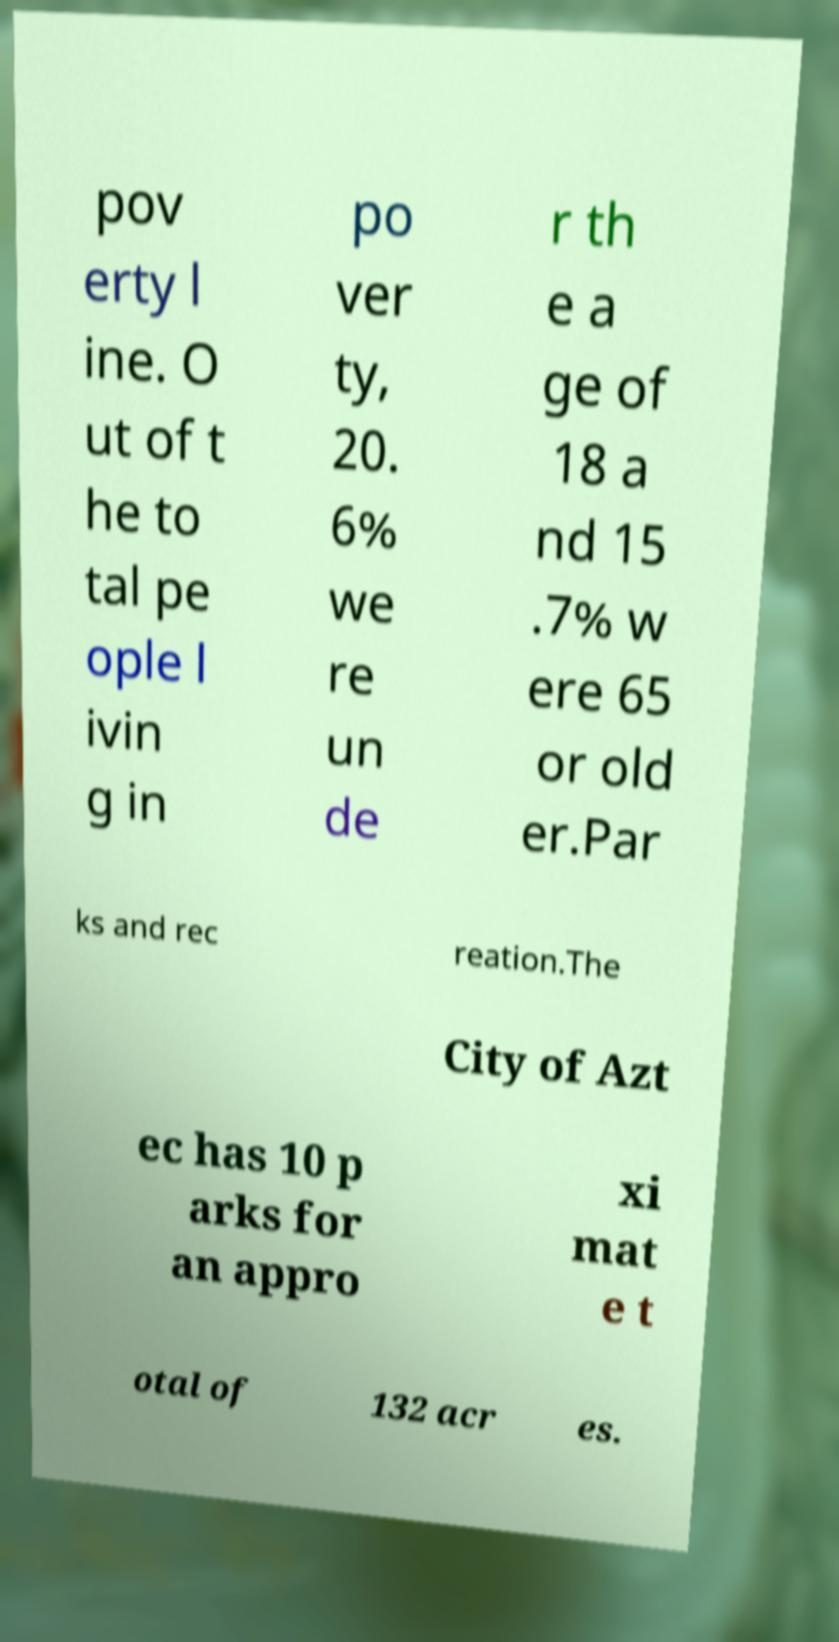Could you assist in decoding the text presented in this image and type it out clearly? pov erty l ine. O ut of t he to tal pe ople l ivin g in po ver ty, 20. 6% we re un de r th e a ge of 18 a nd 15 .7% w ere 65 or old er.Par ks and rec reation.The City of Azt ec has 10 p arks for an appro xi mat e t otal of 132 acr es. 